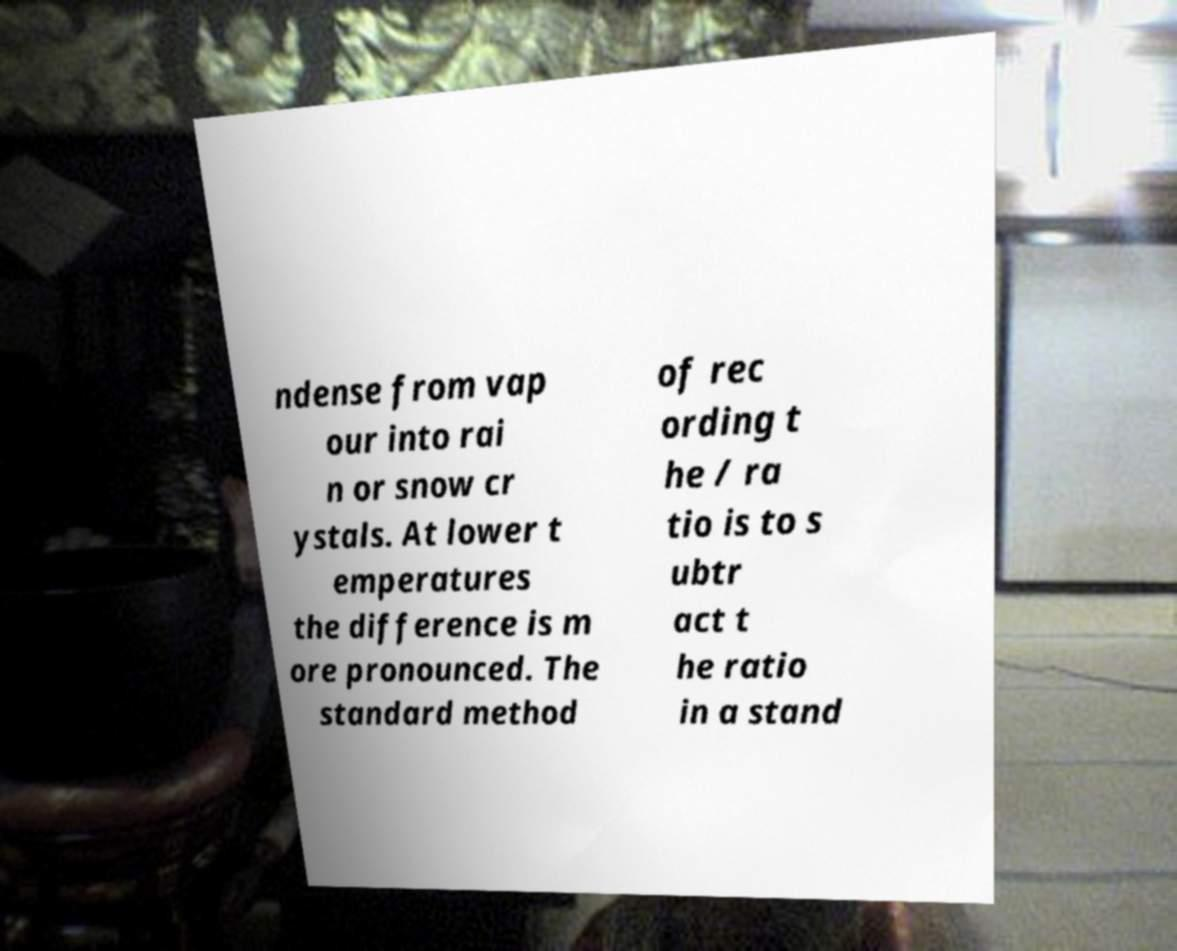What messages or text are displayed in this image? I need them in a readable, typed format. ndense from vap our into rai n or snow cr ystals. At lower t emperatures the difference is m ore pronounced. The standard method of rec ording t he / ra tio is to s ubtr act t he ratio in a stand 